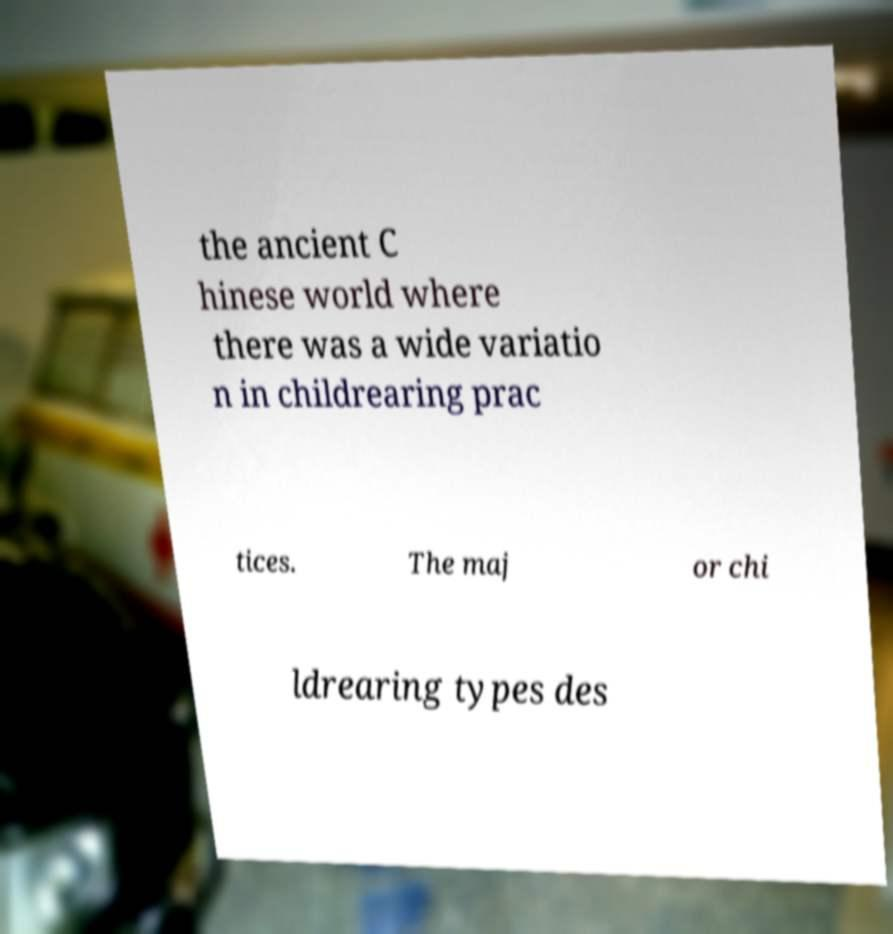Could you assist in decoding the text presented in this image and type it out clearly? the ancient C hinese world where there was a wide variatio n in childrearing prac tices. The maj or chi ldrearing types des 